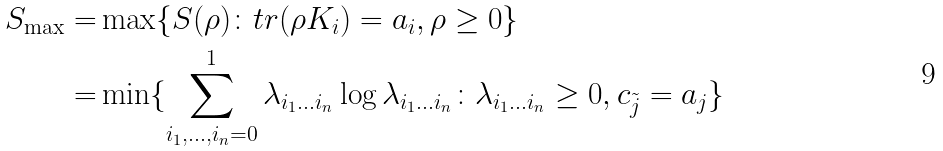Convert formula to latex. <formula><loc_0><loc_0><loc_500><loc_500>S _ { \max } = & \max \{ S ( \rho ) \colon t r ( \rho K _ { i } ) = a _ { i } , \rho \geq 0 \} \\ = & \min \{ \sum _ { i _ { 1 } , \dots , i _ { n } = 0 } ^ { 1 } \lambda _ { i _ { 1 } \dots i _ { n } } \log \lambda _ { i _ { 1 } \dots i _ { n } } \colon \lambda _ { i _ { 1 } \dots i _ { n } } \geq 0 , c _ { \tilde { j } } = a _ { j } \}</formula> 